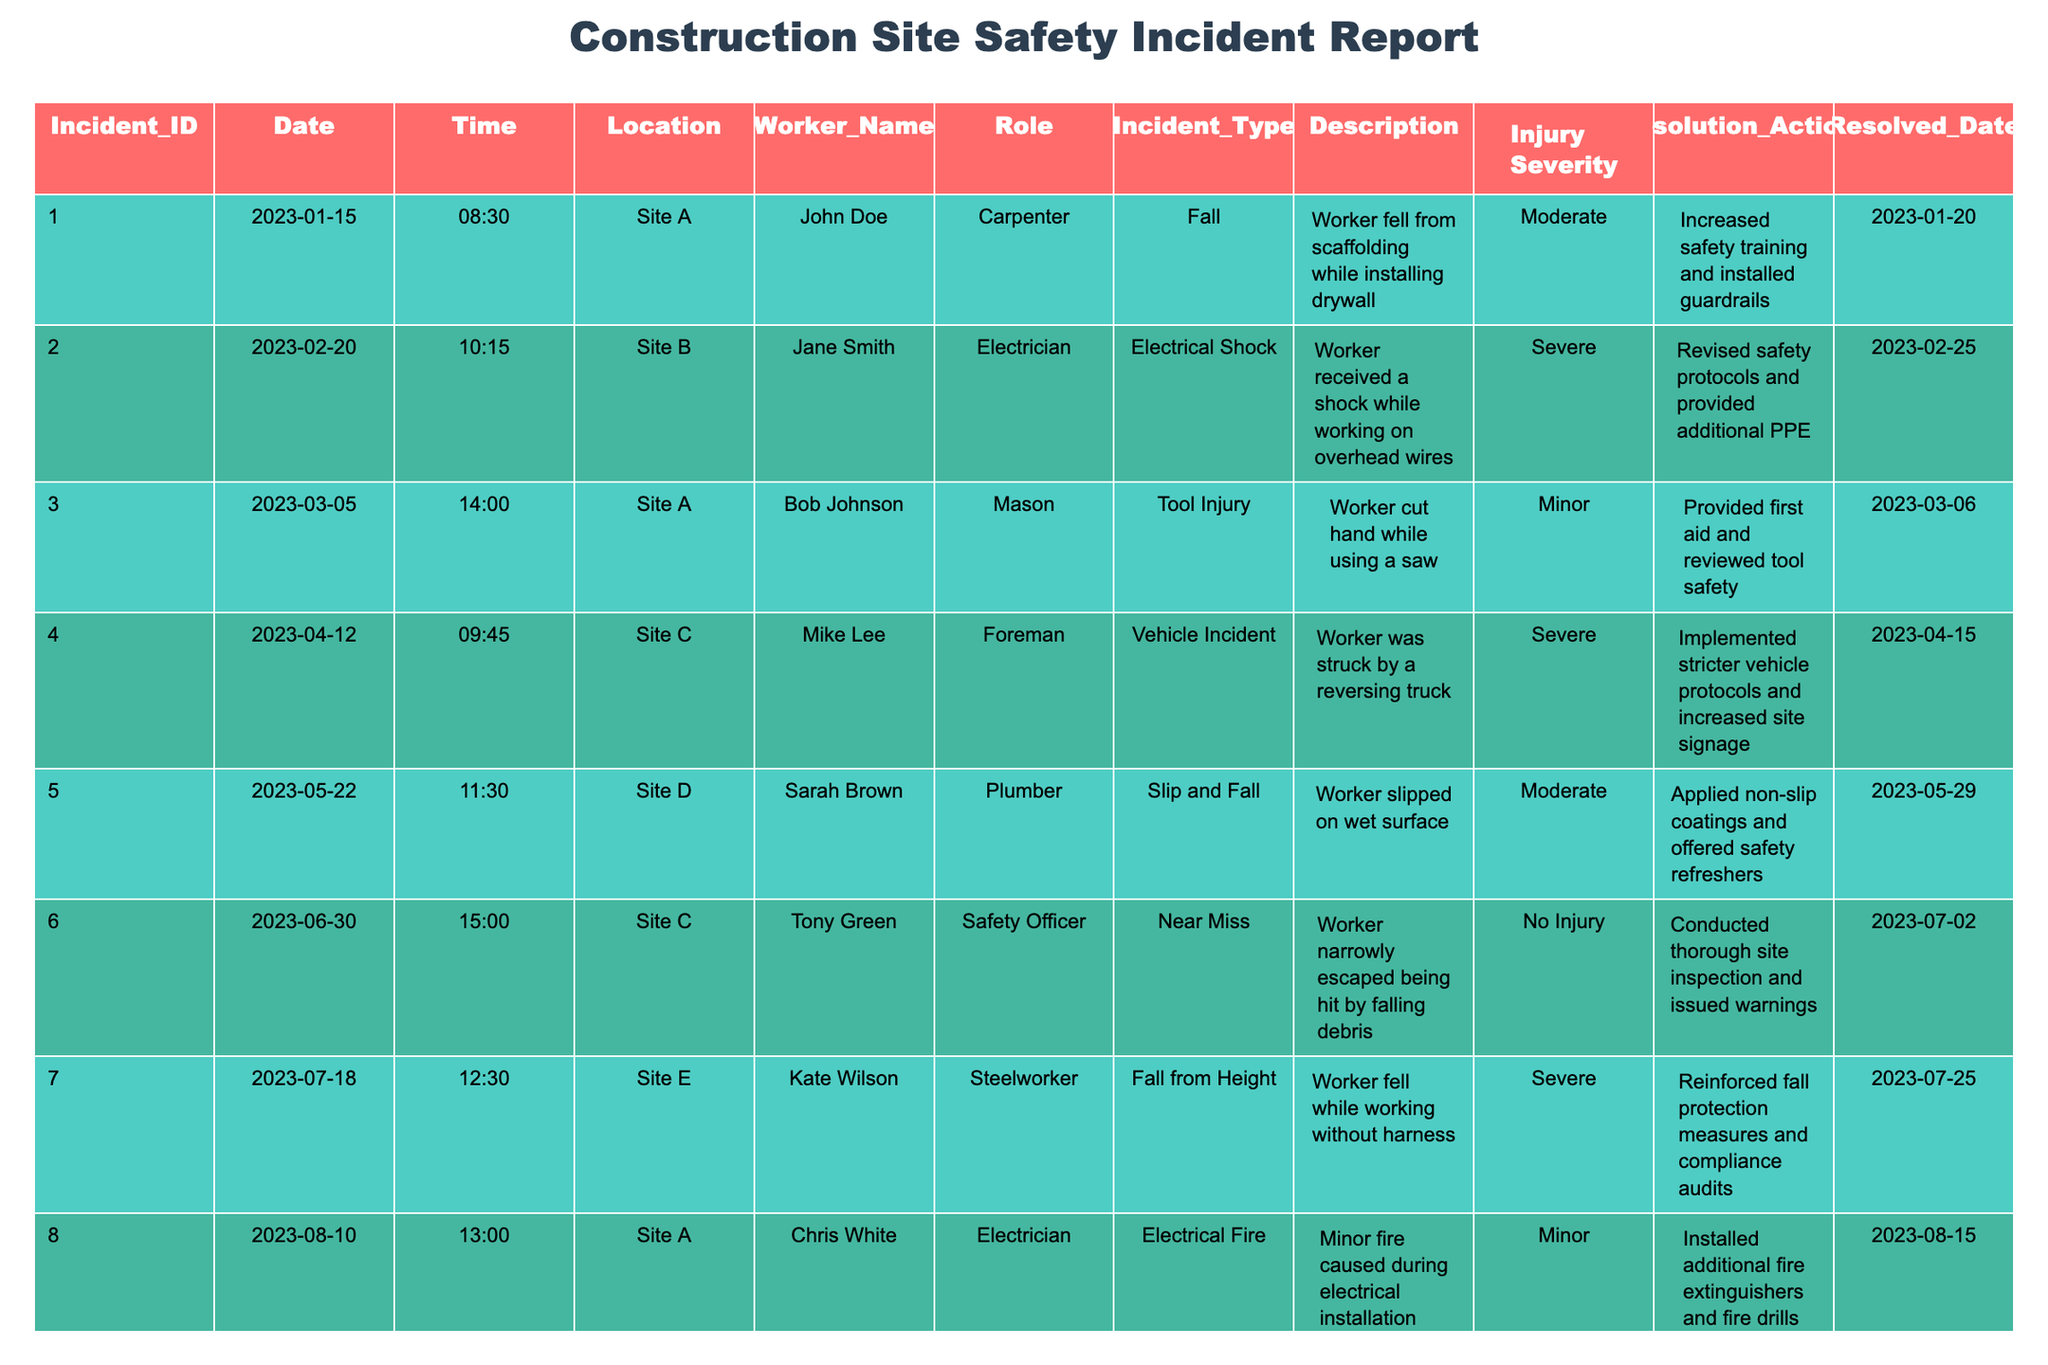What is the incident type for the highest severity reported? The highest severity reported is "Severe," which appears in three incident types: Electrical Shock, Vehicle Incident, and Fall from Height.
Answer: Electrical Shock, Vehicle Incident, Fall from Height How many incidents resulted in a "Moderate" injury severity? There are three incidents with the "Moderate" severity: the fall at Site A, the slip and fall at Site D, and the respiratory issue at Site B.
Answer: 3 What resolution actions were taken for the incident at Site C involving a vehicle incident? For the vehicle incident where a worker was struck, the resolution was to implement stricter vehicle protocols and increase site signage.
Answer: Stricter vehicle protocols and increased site signage Did any incidents occur before March 2023? Yes, the first incident listed occurred on January 15, 2023, which is before March 2023.
Answer: Yes How many incidents involved falls? There are four incidents that involve falls: a fall from scaffolding, a slip and fall, a fall from height, and a minor fire resulting from electrical installation.
Answer: 4 What is the most common type of incident reported in the table? The most common type of incident is fall, with three occurrences: fall from scaffolding, slip and fall, and fall from height.
Answer: Fall What were the top two locations with the most incidents reported? Site A had three incidents, while Site C had two. Thus, the top locations are Site A and Site C.
Answer: Site A and Site C What is the resolution date for the incident with the lowest injury severity? The incident with the lowest severity, "No Injury" due to a near miss, was resolved on July 2, 2023.
Answer: July 2, 2023 How many incidents involved training as a resolution action? There are two incidents where training was involved as a resolution action: increased safety training for a fall and retraining staff on equipment use for a tool malfunction.
Answer: 2 If we account for all incidents, what percentage of them resulted in severe injuries? There are 10 incidents total and 4 were classified as severe. Therefore, the percentage is (4/10)*100 = 40%.
Answer: 40% 